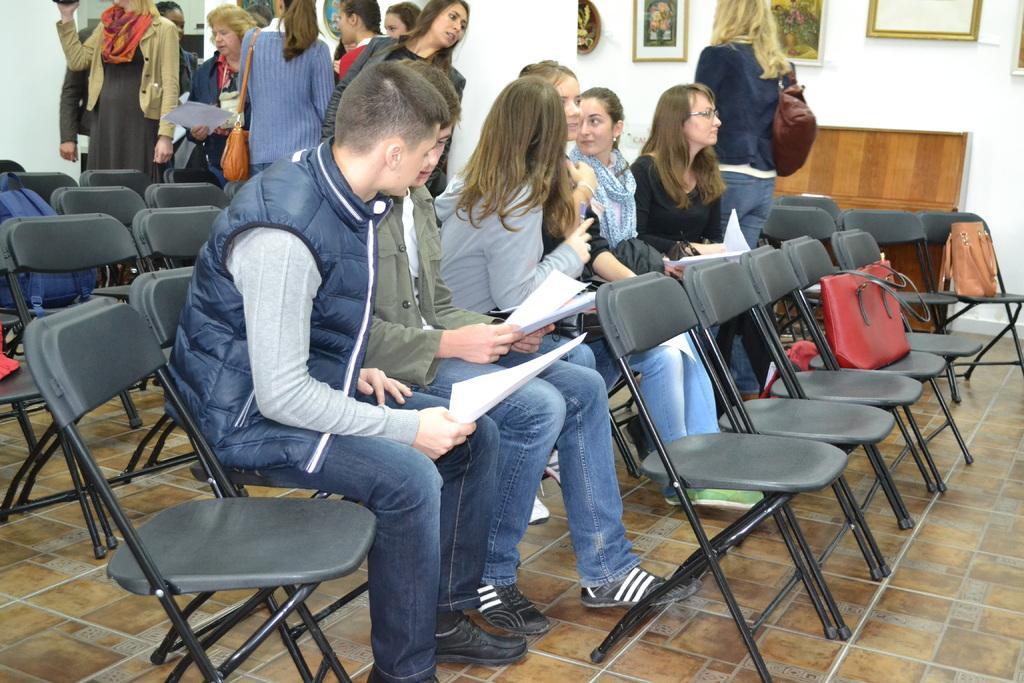Please provide a concise description of this image. In this picture we can see chairs and also fe persons sitting on the chairs by holding papers in their hands. On the background of the picture we can see few women standing. This is us wall. Here we can see frames over the wall. This is a floor. This is a backpack on the chair and these are handbags on the chairs. 